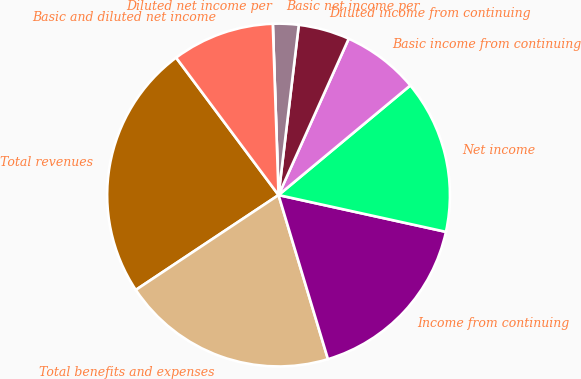Convert chart. <chart><loc_0><loc_0><loc_500><loc_500><pie_chart><fcel>Total revenues<fcel>Total benefits and expenses<fcel>Income from continuing<fcel>Net income<fcel>Basic income from continuing<fcel>Diluted income from continuing<fcel>Basic net income per<fcel>Diluted net income per<fcel>Basic and diluted net income<nl><fcel>24.14%<fcel>20.32%<fcel>16.9%<fcel>14.49%<fcel>7.24%<fcel>4.83%<fcel>2.42%<fcel>0.0%<fcel>9.66%<nl></chart> 